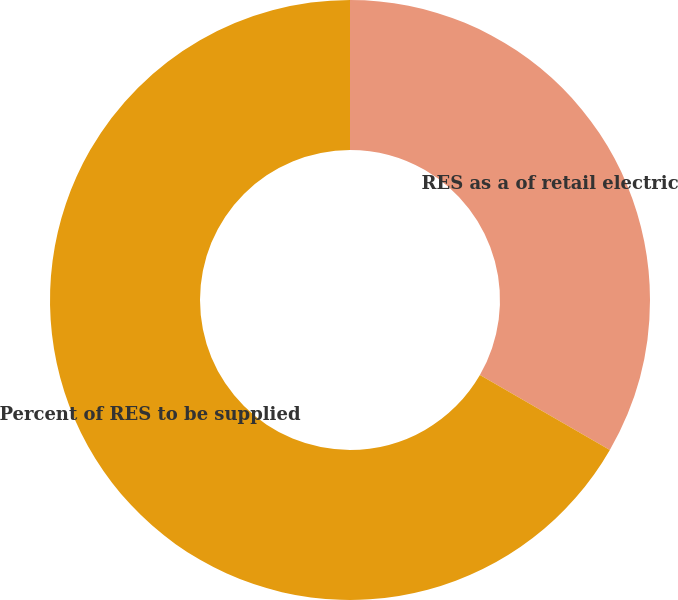Convert chart to OTSL. <chart><loc_0><loc_0><loc_500><loc_500><pie_chart><fcel>RES as a of retail electric<fcel>Percent of RES to be supplied<nl><fcel>33.33%<fcel>66.67%<nl></chart> 